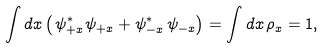<formula> <loc_0><loc_0><loc_500><loc_500>\int d x \left ( \, \psi _ { + x } ^ { \ast } \psi _ { + x } + \psi _ { - x } ^ { \ast } \, \psi _ { - x } \right ) = \int d x \, \rho _ { x } = 1 ,</formula> 